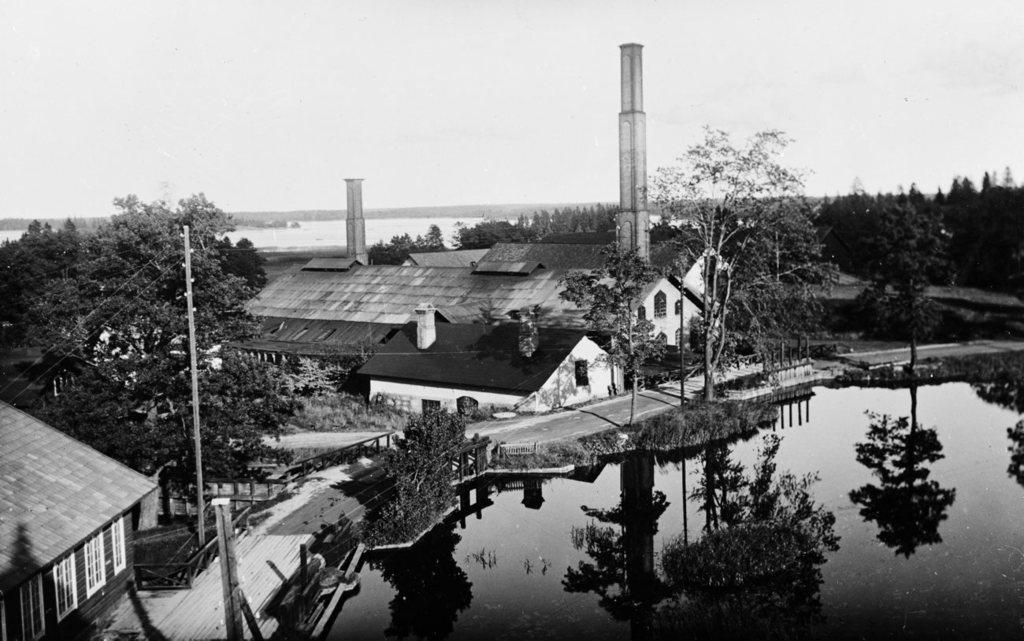What type of structures can be seen in the image? There are houses in the image. What other natural elements are present in the image? There are trees and water visible in the image. What is visible in the background of the image? The sky is visible in the image. How many eggs are being carried by the deer in the image? There is no deer or eggs present in the image. What type of rock formation can be seen in the image? There is no rock formation present in the image. 